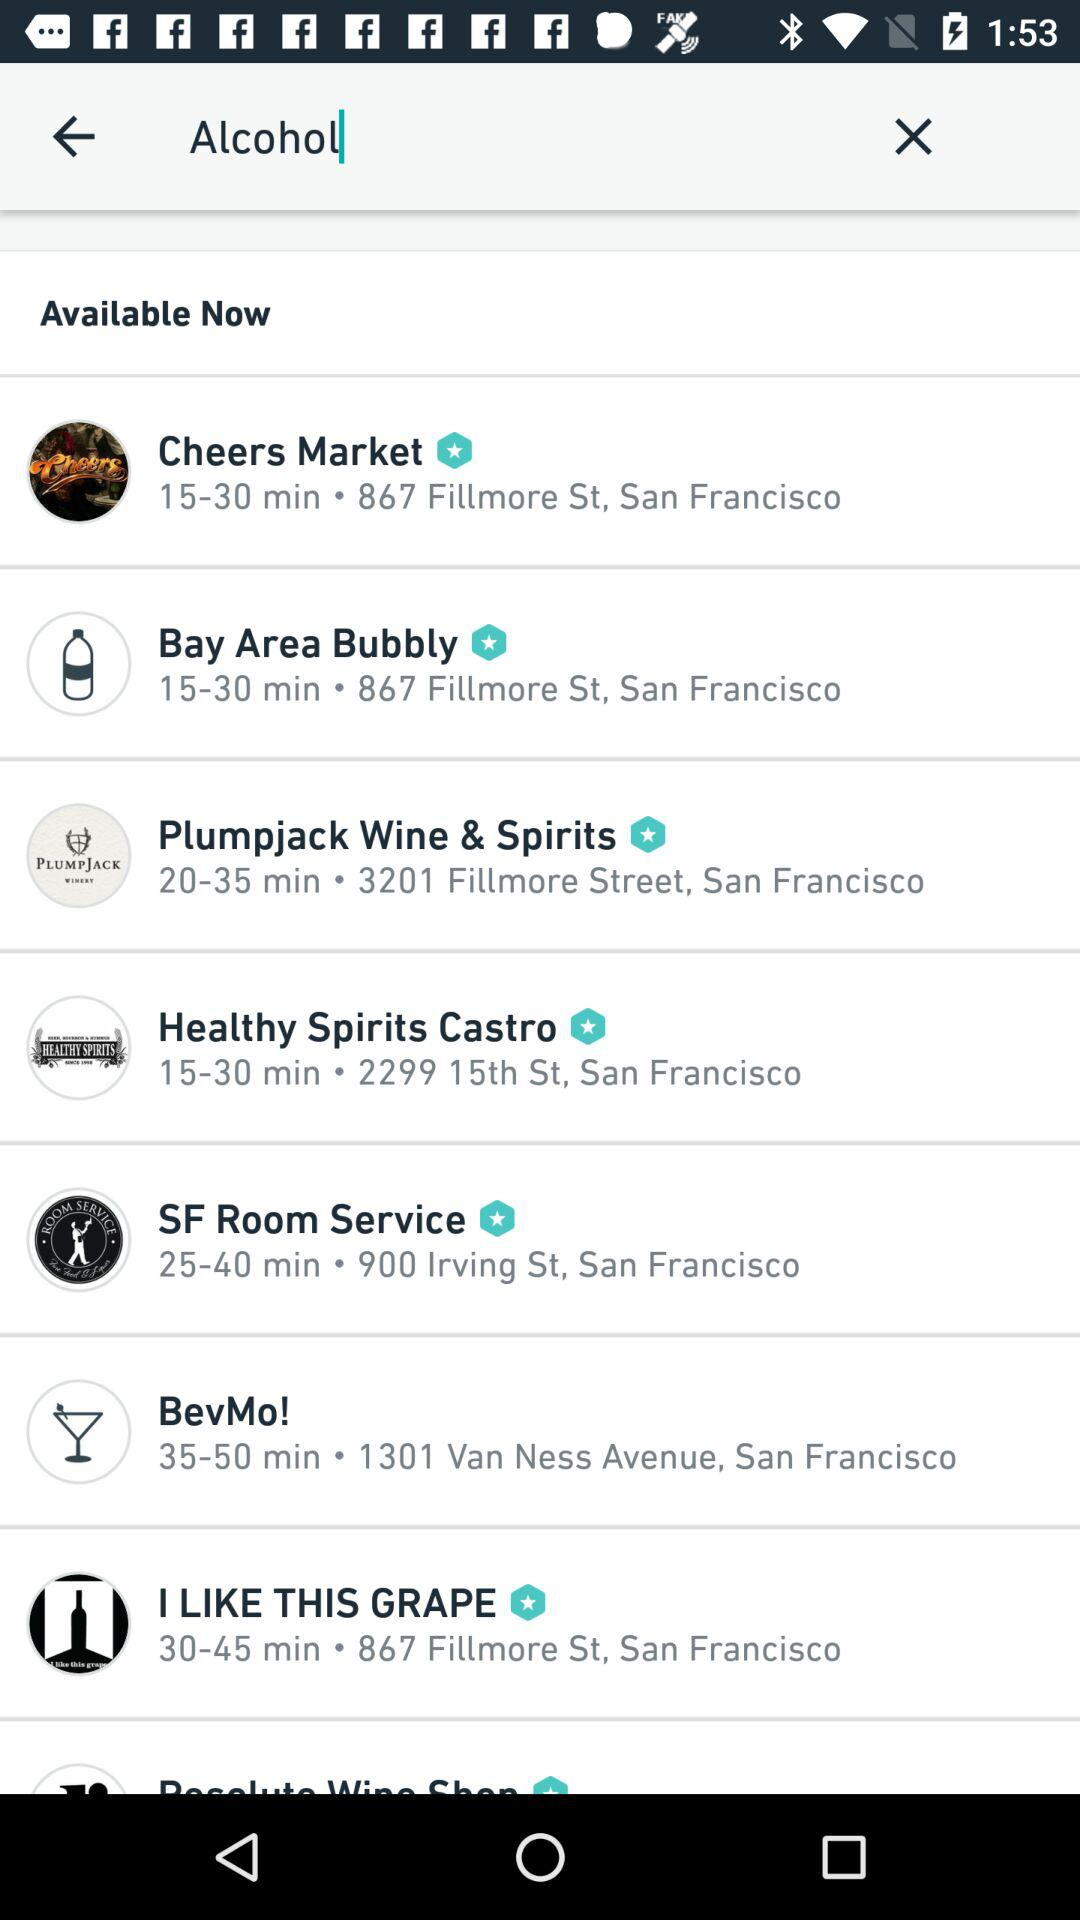Where is "Healthy Spirits" located in Castro? It is located at 2299 15th Street, San Francisco. 